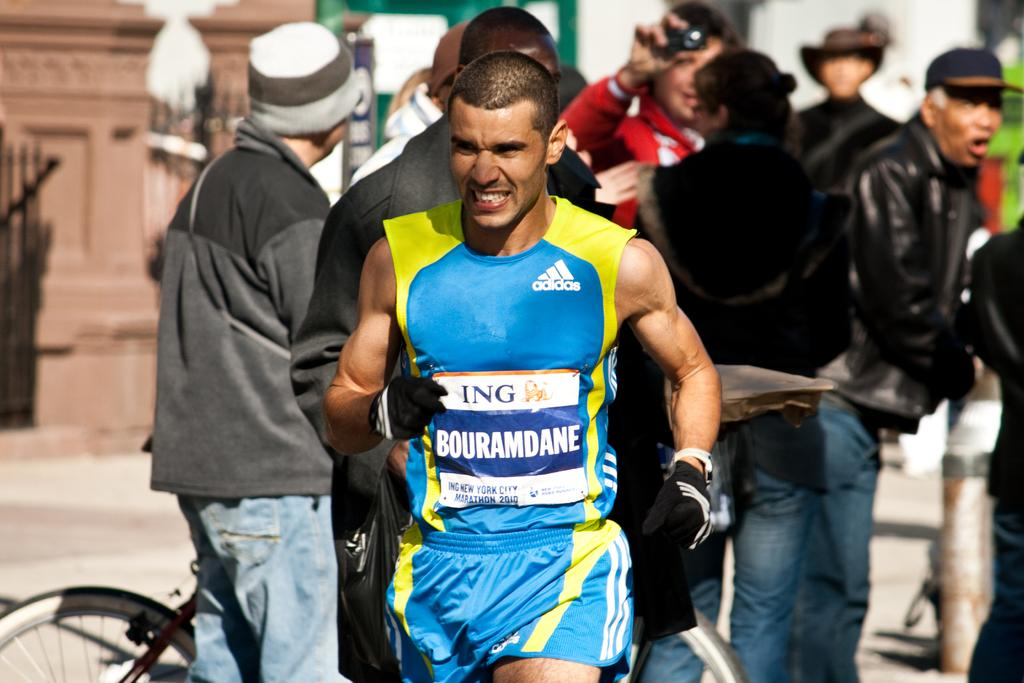<image>
Render a clear and concise summary of the photo. A man runs in the New York City Marathon sponsored by ING. 